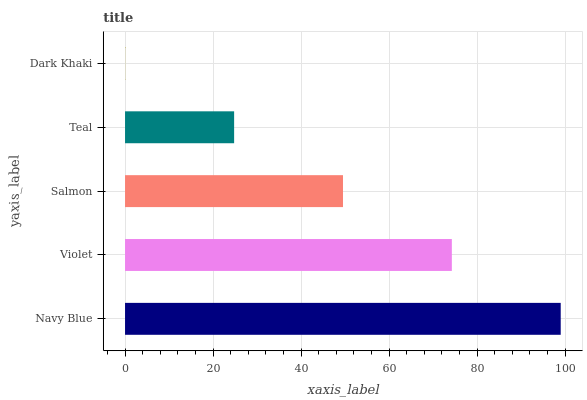Is Dark Khaki the minimum?
Answer yes or no. Yes. Is Navy Blue the maximum?
Answer yes or no. Yes. Is Violet the minimum?
Answer yes or no. No. Is Violet the maximum?
Answer yes or no. No. Is Navy Blue greater than Violet?
Answer yes or no. Yes. Is Violet less than Navy Blue?
Answer yes or no. Yes. Is Violet greater than Navy Blue?
Answer yes or no. No. Is Navy Blue less than Violet?
Answer yes or no. No. Is Salmon the high median?
Answer yes or no. Yes. Is Salmon the low median?
Answer yes or no. Yes. Is Violet the high median?
Answer yes or no. No. Is Navy Blue the low median?
Answer yes or no. No. 